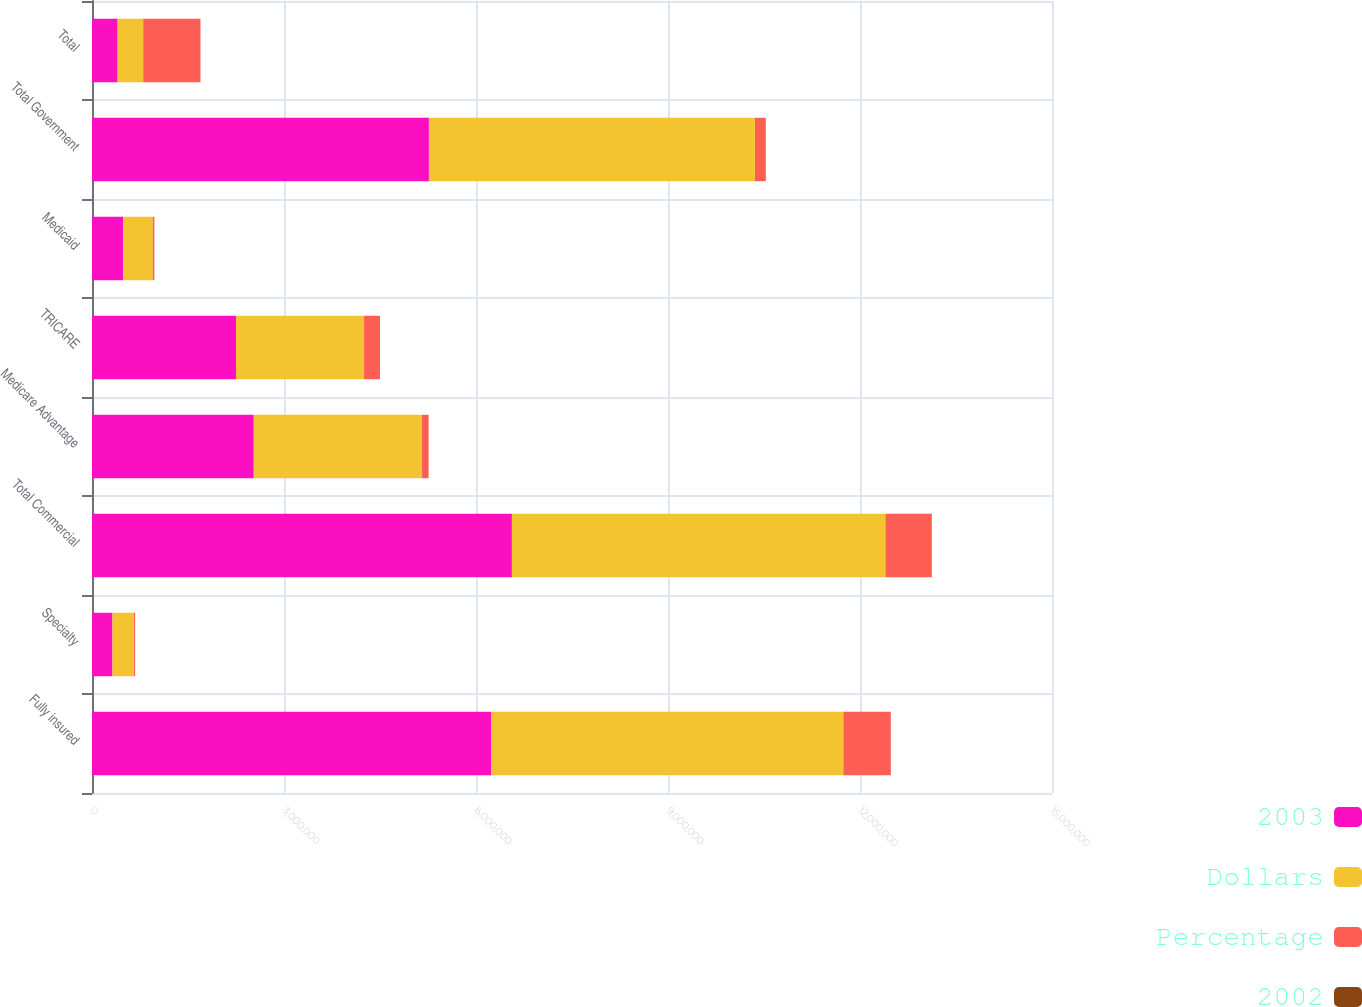Convert chart to OTSL. <chart><loc_0><loc_0><loc_500><loc_500><stacked_bar_chart><ecel><fcel>Fully insured<fcel>Specialty<fcel>Total Commercial<fcel>Medicare Advantage<fcel>TRICARE<fcel>Medicaid<fcel>Total Government<fcel>Total<nl><fcel>2003<fcel>6.24081e+06<fcel>320206<fcel>6.56101e+06<fcel>2.52745e+06<fcel>2.24972e+06<fcel>487100<fcel>5.26427e+06<fcel>400146<nl><fcel>Dollars<fcel>5.49903e+06<fcel>337295<fcel>5.83633e+06<fcel>2.6296e+06<fcel>2.00147e+06<fcel>462998<fcel>5.09407e+06<fcel>400146<nl><fcel>Percentage<fcel>741773<fcel>17089<fcel>724684<fcel>102151<fcel>248251<fcel>24102<fcel>170202<fcel>894886<nl><fcel>2002<fcel>13.5<fcel>5.1<fcel>12.4<fcel>3.9<fcel>12.4<fcel>5.2<fcel>3.3<fcel>8.2<nl></chart> 